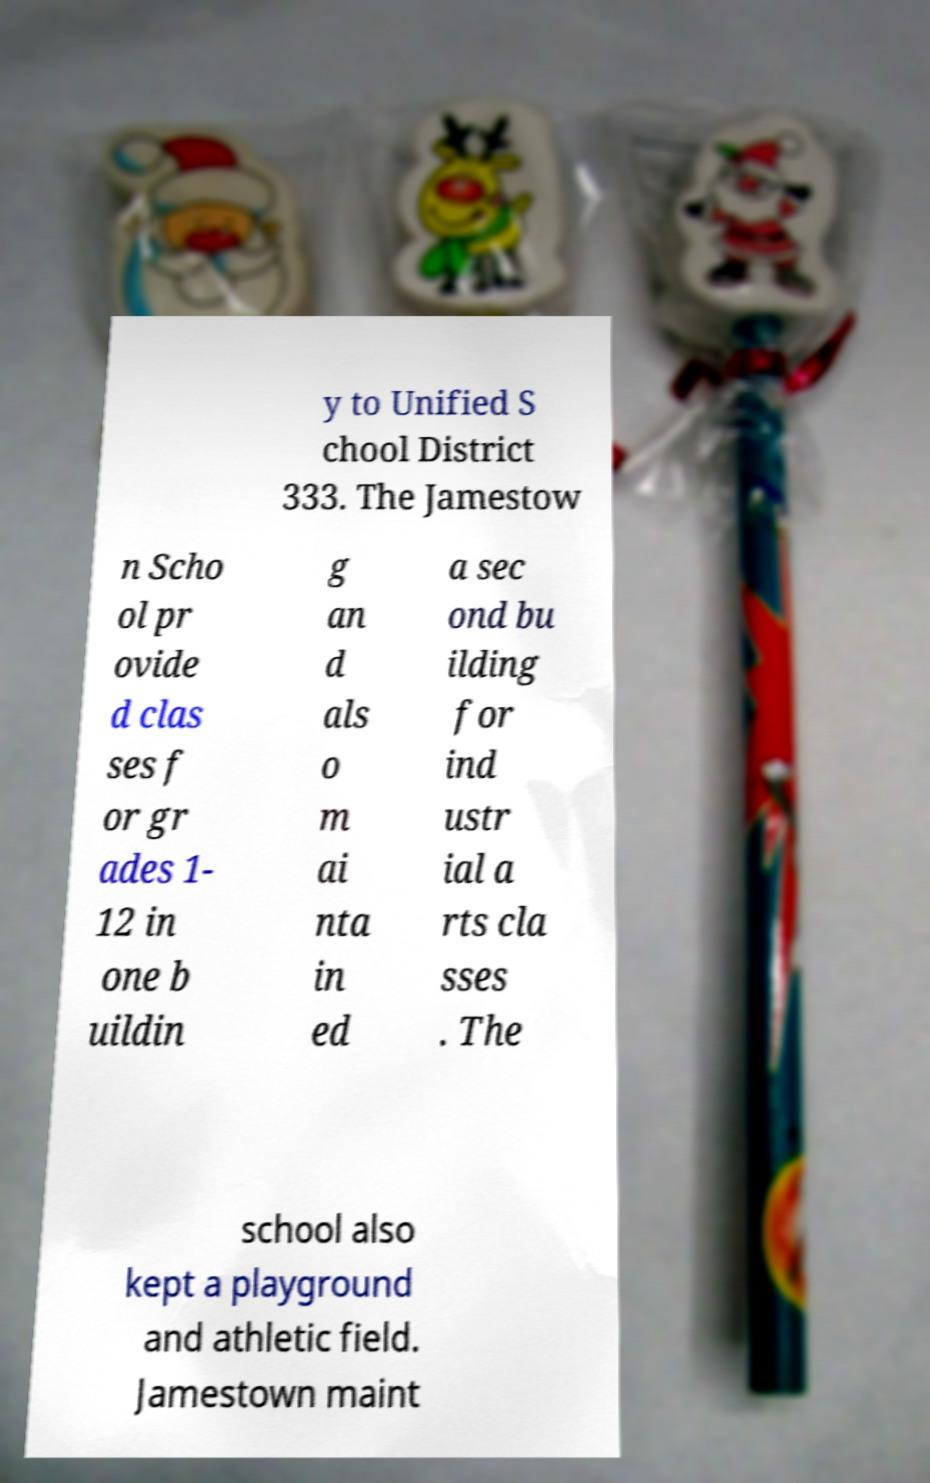For documentation purposes, I need the text within this image transcribed. Could you provide that? y to Unified S chool District 333. The Jamestow n Scho ol pr ovide d clas ses f or gr ades 1- 12 in one b uildin g an d als o m ai nta in ed a sec ond bu ilding for ind ustr ial a rts cla sses . The school also kept a playground and athletic field. Jamestown maint 